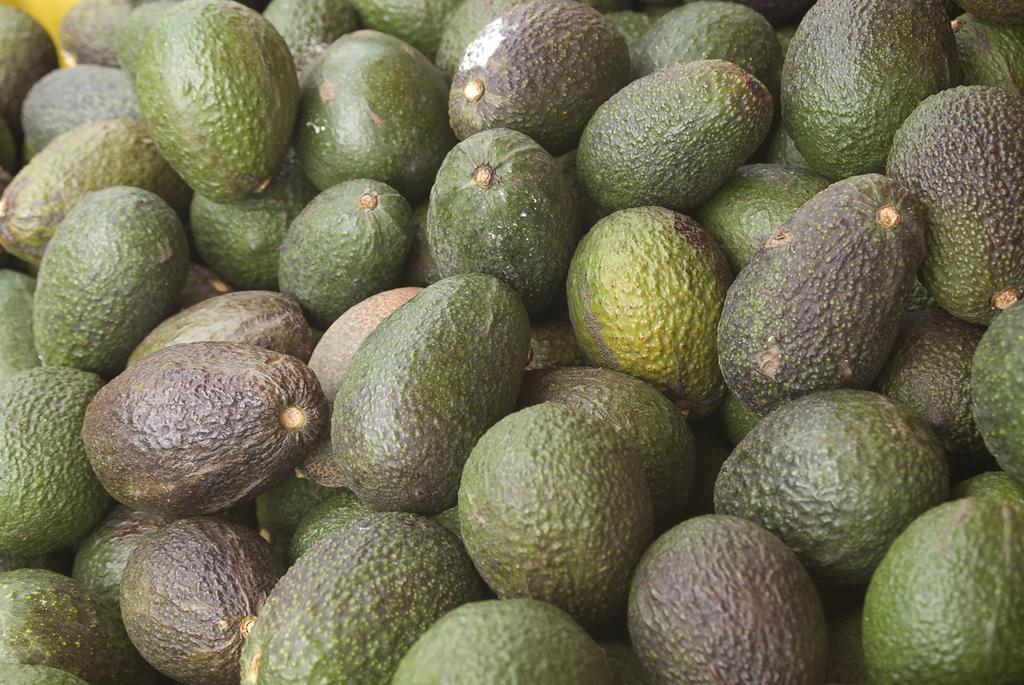Please provide a concise description of this image. In this picture we can see many green color Avogadro fruits seen in the image. 